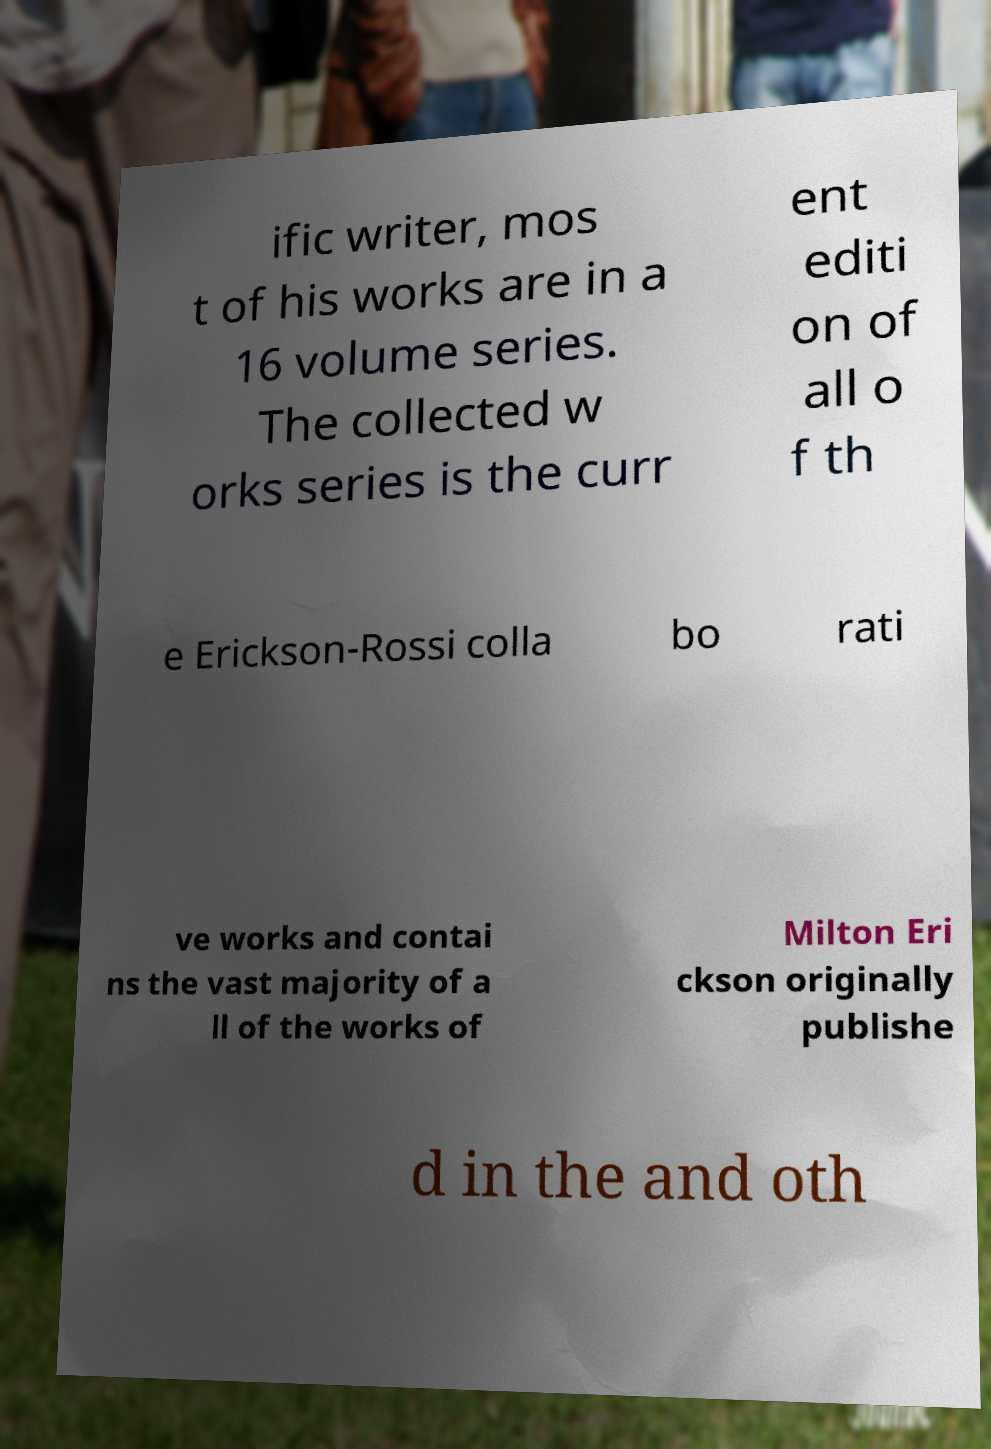Please read and relay the text visible in this image. What does it say? ific writer, mos t of his works are in a 16 volume series. The collected w orks series is the curr ent editi on of all o f th e Erickson-Rossi colla bo rati ve works and contai ns the vast majority of a ll of the works of Milton Eri ckson originally publishe d in the and oth 